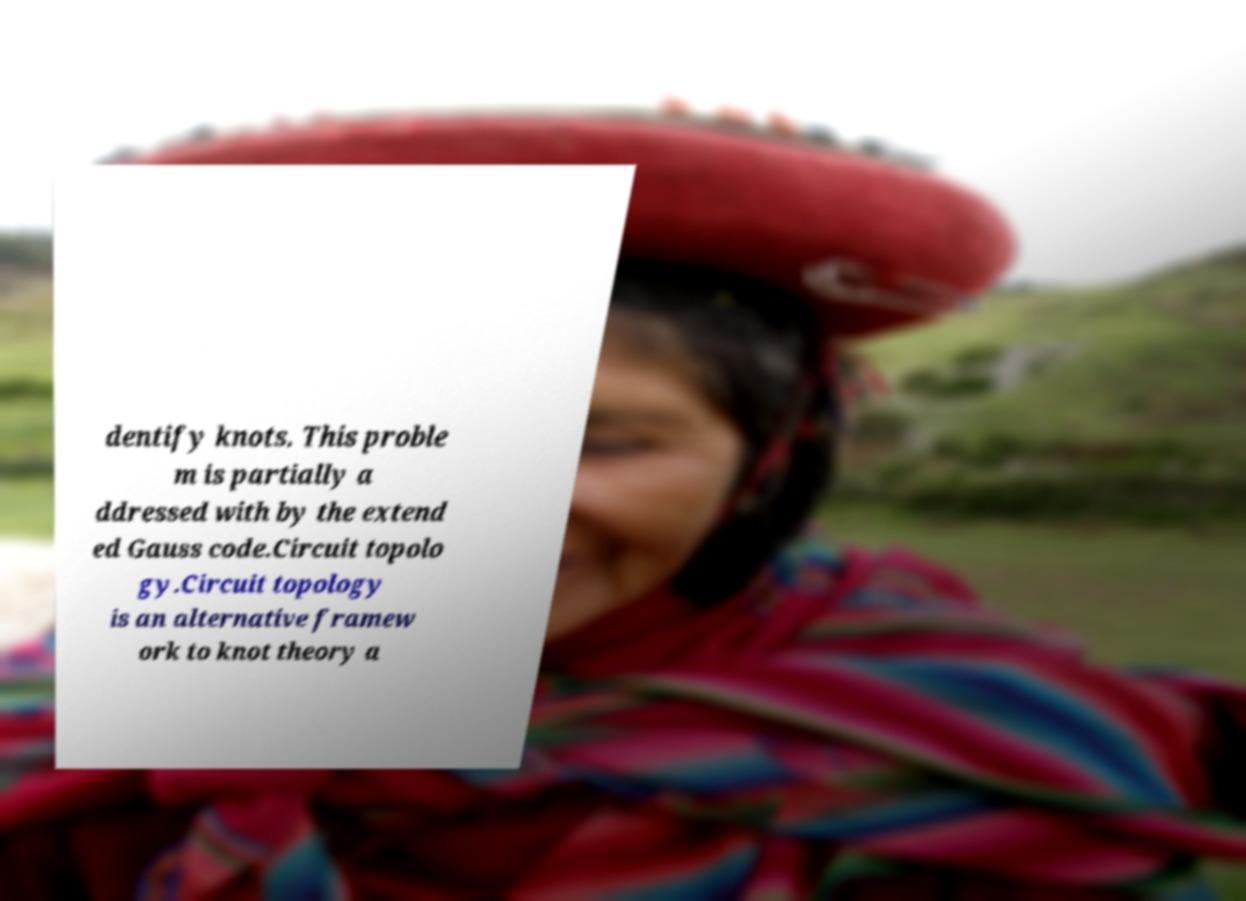Could you extract and type out the text from this image? dentify knots. This proble m is partially a ddressed with by the extend ed Gauss code.Circuit topolo gy.Circuit topology is an alternative framew ork to knot theory a 